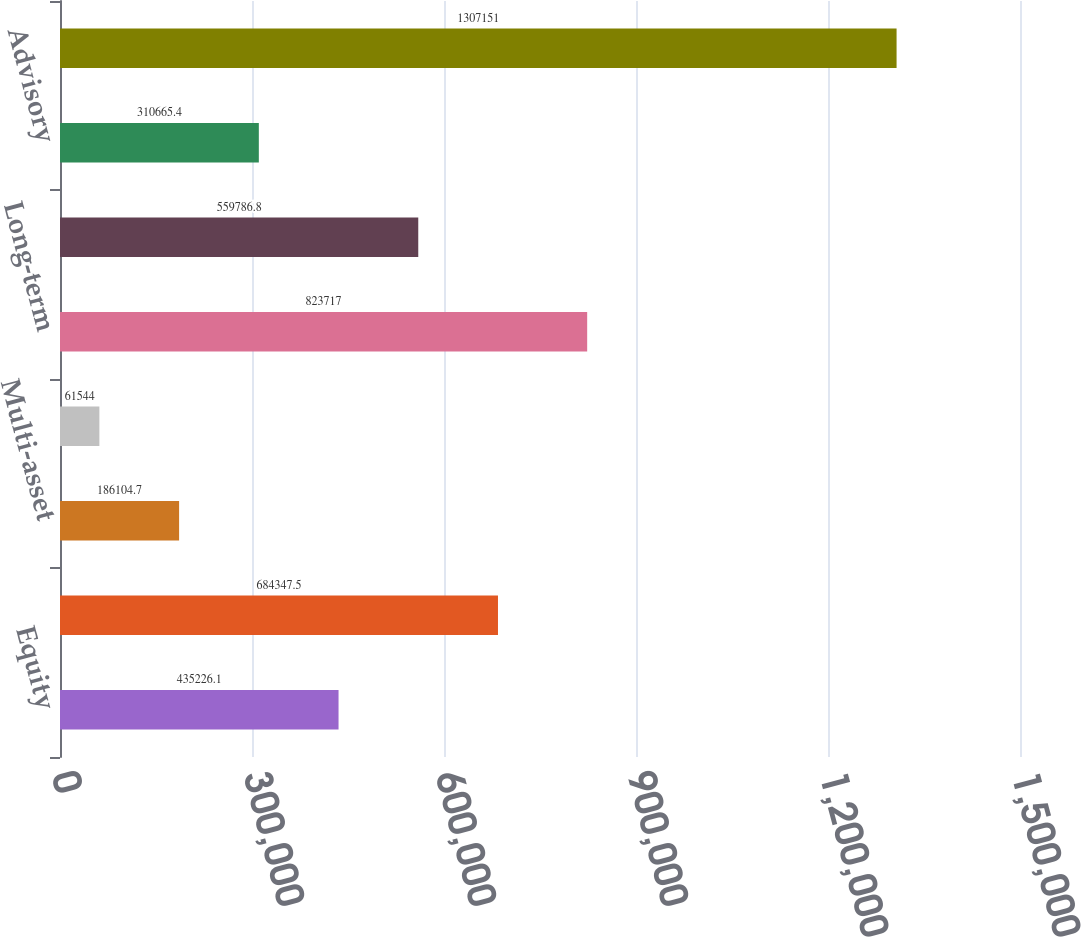Convert chart. <chart><loc_0><loc_0><loc_500><loc_500><bar_chart><fcel>Equity<fcel>Fixed income<fcel>Multi-asset<fcel>Alternatives<fcel>Long-term<fcel>Cash management<fcel>Advisory<fcel>Total<nl><fcel>435226<fcel>684348<fcel>186105<fcel>61544<fcel>823717<fcel>559787<fcel>310665<fcel>1.30715e+06<nl></chart> 